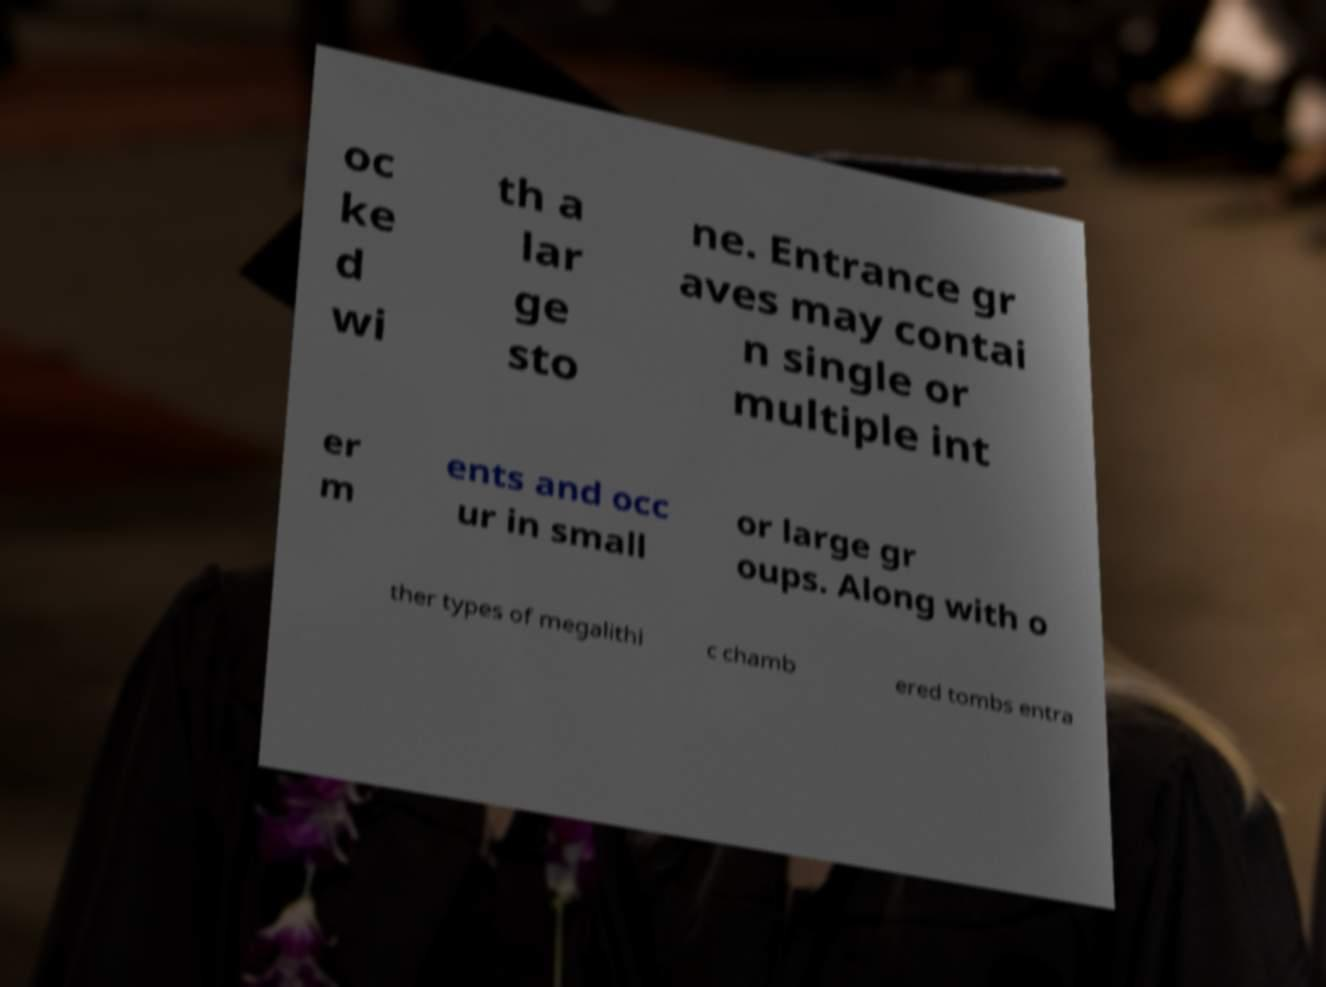Could you assist in decoding the text presented in this image and type it out clearly? oc ke d wi th a lar ge sto ne. Entrance gr aves may contai n single or multiple int er m ents and occ ur in small or large gr oups. Along with o ther types of megalithi c chamb ered tombs entra 